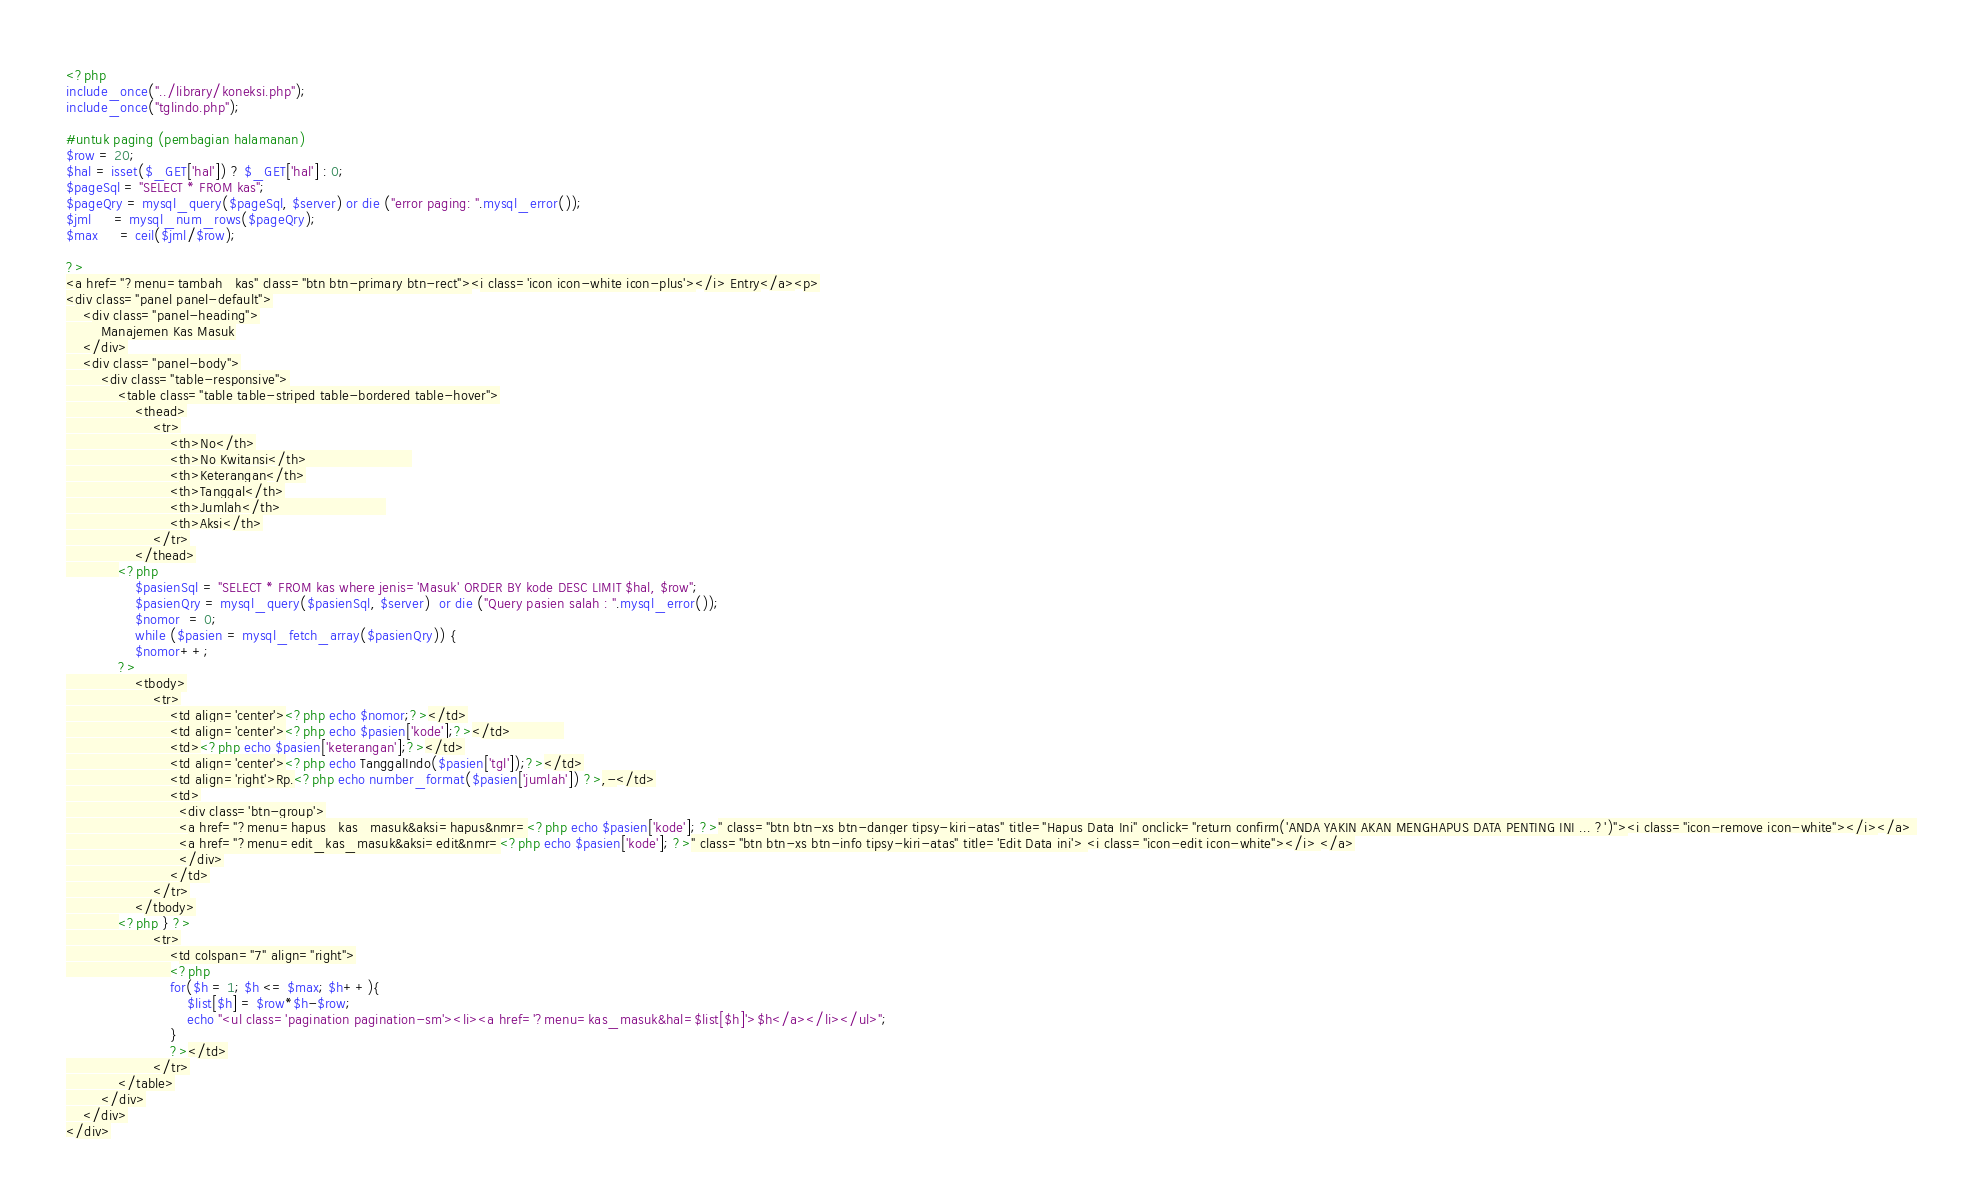Convert code to text. <code><loc_0><loc_0><loc_500><loc_500><_PHP_><?php
include_once("../library/koneksi.php");
include_once("tglindo.php");

#untuk paging (pembagian halamanan)
$row = 20;
$hal = isset($_GET['hal']) ? $_GET['hal'] : 0;
$pageSql = "SELECT * FROM kas";
$pageQry = mysql_query($pageSql, $server) or die ("error paging: ".mysql_error());
$jml	 = mysql_num_rows($pageQry);
$max	 = ceil($jml/$row);

?>
<a href="?menu=tambah_kas" class="btn btn-primary btn-rect"><i class='icon icon-white icon-plus'></i> Entry</a><p>
<div class="panel panel-default">
	<div class="panel-heading">
		Manajemen Kas Masuk
	</div>
	<div class="panel-body">
		<div class="table-responsive">
			<table class="table table-striped table-bordered table-hover">
				<thead>
					<tr>
						<th>No</th>
						<th>No Kwitansi</th>						
						<th>Keterangan</th>
						<th>Tanggal</th>
						<th>Jumlah</th>						
						<th>Aksi</th>
					</tr>
				</thead>
			<?php
				$pasienSql = "SELECT * FROM kas where jenis='Masuk' ORDER BY kode DESC LIMIT $hal, $row";
				$pasienQry = mysql_query($pasienSql, $server)  or die ("Query pasien salah : ".mysql_error());
				$nomor  = 0; 
				while ($pasien = mysql_fetch_array($pasienQry)) {
				$nomor++;
			?>
				<tbody>
					<tr>
						<td align='center'><?php echo $nomor;?></td>
						<td align='center'><?php echo $pasien['kode'];?></td>			
						<td><?php echo $pasien['keterangan'];?></td>
						<td align='center'><?php echo TanggalIndo($pasien['tgl']);?></td>
						<td align='right'>Rp.<?php echo number_format($pasien['jumlah']) ?>,-</td>
						<td>
						  <div class='btn-group'>
						  <a href="?menu=hapus_kas_masuk&aksi=hapus&nmr=<?php echo $pasien['kode']; ?>" class="btn btn-xs btn-danger tipsy-kiri-atas" title="Hapus Data Ini" onclick="return confirm('ANDA YAKIN AKAN MENGHAPUS DATA PENTING INI ... ?')"><i class="icon-remove icon-white"></i></a> 
						  <a href="?menu=edit_kas_masuk&aksi=edit&nmr=<?php echo $pasien['kode']; ?>" class="btn btn-xs btn-info tipsy-kiri-atas" title='Edit Data ini'> <i class="icon-edit icon-white"></i> </a>
						  </div>
						</td>
					</tr>
				</tbody>
			<?php } ?>
					<tr>
						<td colspan="7" align="right">
						<?php
						for($h = 1; $h <= $max; $h++){
							$list[$h] = $row*$h-$row;
							echo "<ul class='pagination pagination-sm'><li><a href='?menu=kas_masuk&hal=$list[$h]'>$h</a></li></ul>";
						}
						?></td>
					</tr>
			</table>
		</div>
	</div>
</div></code> 